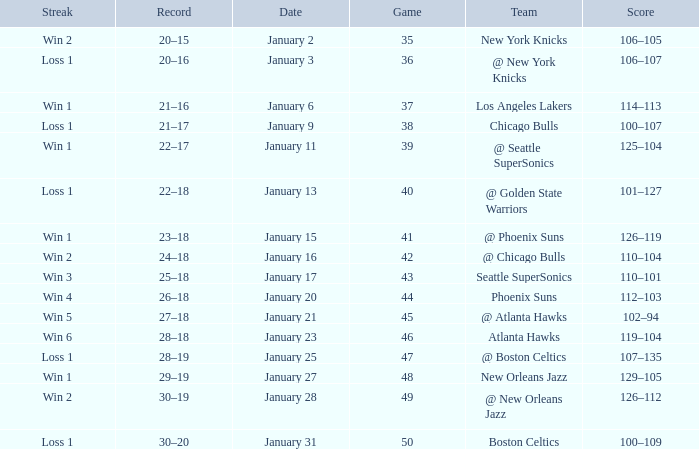What is the Team in Game 41? @ Phoenix Suns. 